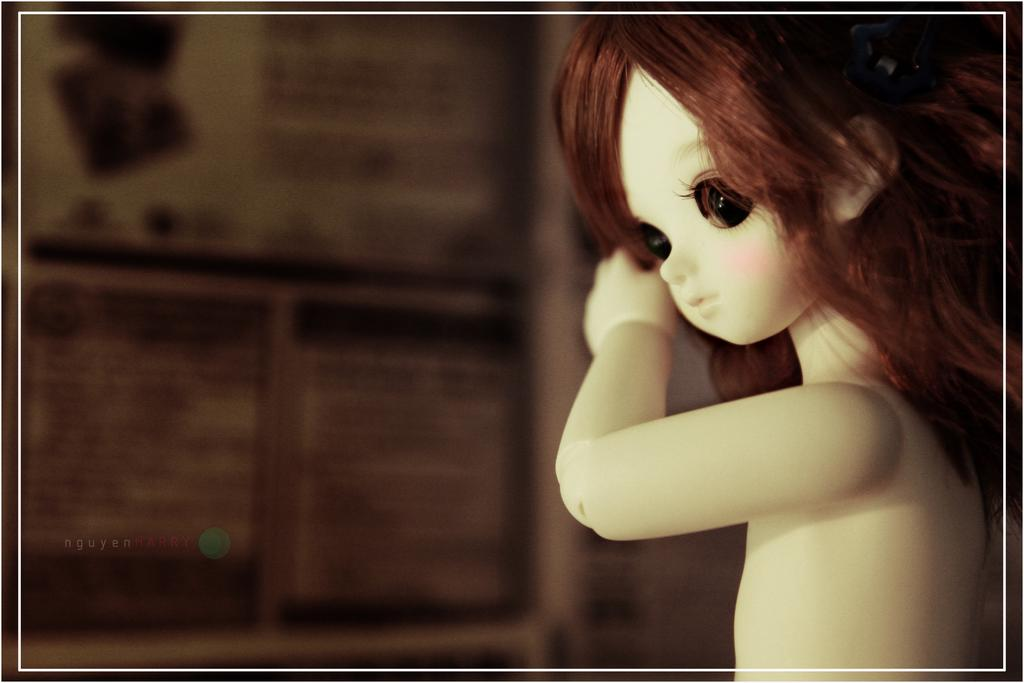What is the color of the doll in the image? The doll in the image is white. What is the color of the doll's hair? The doll has brown color hair. What is the color of the doll's eyes? The doll has black color eyes. Can you describe the background of the image? The background of the image is blurred. What type of jar is the doll holding in the image? There is no jar present in the image; the doll is not holding anything. 